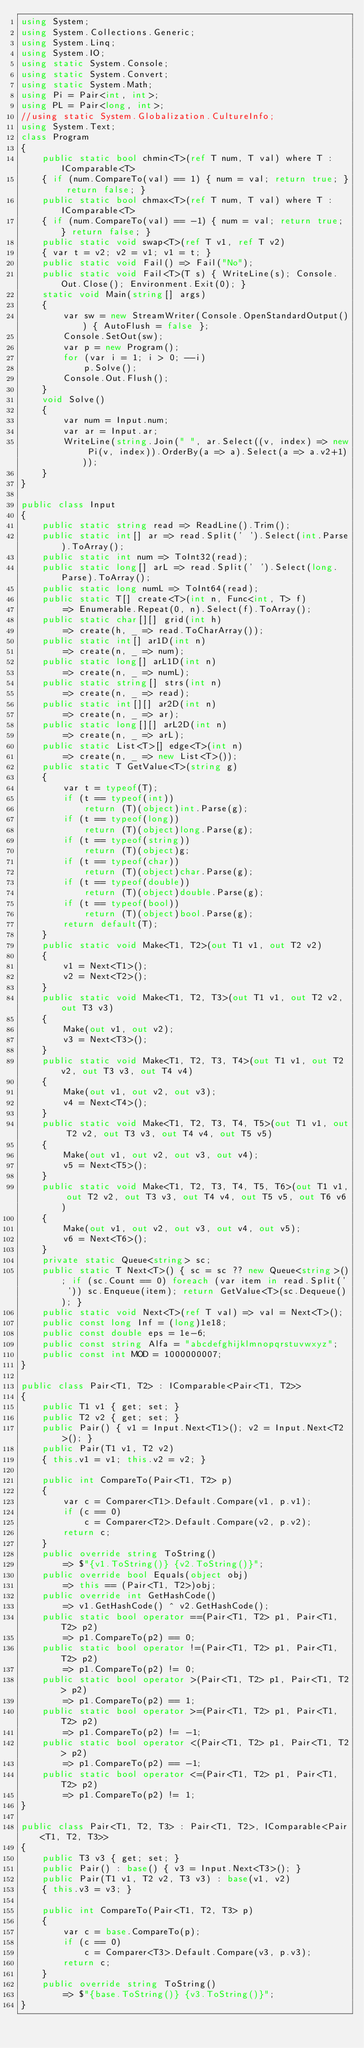<code> <loc_0><loc_0><loc_500><loc_500><_C#_>using System;
using System.Collections.Generic;
using System.Linq;
using System.IO;
using static System.Console;
using static System.Convert;
using static System.Math;
using Pi = Pair<int, int>;
using PL = Pair<long, int>;
//using static System.Globalization.CultureInfo;
using System.Text;
class Program
{
    public static bool chmin<T>(ref T num, T val) where T : IComparable<T>
    { if (num.CompareTo(val) == 1) { num = val; return true; } return false; }
    public static bool chmax<T>(ref T num, T val) where T : IComparable<T>
    { if (num.CompareTo(val) == -1) { num = val; return true; } return false; }
    public static void swap<T>(ref T v1, ref T v2)
    { var t = v2; v2 = v1; v1 = t; }
    public static void Fail() => Fail("No");
    public static void Fail<T>(T s) { WriteLine(s); Console.Out.Close(); Environment.Exit(0); }
    static void Main(string[] args)
    {
        var sw = new StreamWriter(Console.OpenStandardOutput()) { AutoFlush = false };
        Console.SetOut(sw);
        var p = new Program();
        for (var i = 1; i > 0; --i) 
            p.Solve();
        Console.Out.Flush();
    }
    void Solve()
    {
        var num = Input.num;
        var ar = Input.ar;
        WriteLine(string.Join(" ", ar.Select((v, index) => new Pi(v, index)).OrderBy(a => a).Select(a => a.v2+1)));
    }
}

public class Input
{
    public static string read => ReadLine().Trim();
    public static int[] ar => read.Split(' ').Select(int.Parse).ToArray();
    public static int num => ToInt32(read);
    public static long[] arL => read.Split(' ').Select(long.Parse).ToArray();
    public static long numL => ToInt64(read);
    public static T[] create<T>(int n, Func<int, T> f)
        => Enumerable.Repeat(0, n).Select(f).ToArray();
    public static char[][] grid(int h)
        => create(h, _ => read.ToCharArray());
    public static int[] ar1D(int n)
        => create(n, _ => num);
    public static long[] arL1D(int n)
        => create(n, _ => numL);
    public static string[] strs(int n)
        => create(n, _ => read);
    public static int[][] ar2D(int n)
        => create(n, _ => ar);
    public static long[][] arL2D(int n)
        => create(n, _ => arL);
    public static List<T>[] edge<T>(int n)
        => create(n, _ => new List<T>());
    public static T GetValue<T>(string g)
    {
        var t = typeof(T);
        if (t == typeof(int))
            return (T)(object)int.Parse(g);
        if (t == typeof(long))
            return (T)(object)long.Parse(g);
        if (t == typeof(string))
            return (T)(object)g;
        if (t == typeof(char))
            return (T)(object)char.Parse(g);
        if (t == typeof(double))
            return (T)(object)double.Parse(g);
        if (t == typeof(bool))
            return (T)(object)bool.Parse(g);
        return default(T);
    }
    public static void Make<T1, T2>(out T1 v1, out T2 v2)
    {
        v1 = Next<T1>();
        v2 = Next<T2>();
    }
    public static void Make<T1, T2, T3>(out T1 v1, out T2 v2, out T3 v3)
    {
        Make(out v1, out v2);
        v3 = Next<T3>();
    }
    public static void Make<T1, T2, T3, T4>(out T1 v1, out T2 v2, out T3 v3, out T4 v4)
    {
        Make(out v1, out v2, out v3);
        v4 = Next<T4>();
    }
    public static void Make<T1, T2, T3, T4, T5>(out T1 v1, out T2 v2, out T3 v3, out T4 v4, out T5 v5)
    {
        Make(out v1, out v2, out v3, out v4);
        v5 = Next<T5>();
    }
    public static void Make<T1, T2, T3, T4, T5, T6>(out T1 v1, out T2 v2, out T3 v3, out T4 v4, out T5 v5, out T6 v6)
    {
        Make(out v1, out v2, out v3, out v4, out v5);
        v6 = Next<T6>();
    }
    private static Queue<string> sc;
    public static T Next<T>() { sc = sc ?? new Queue<string>(); if (sc.Count == 0) foreach (var item in read.Split(' ')) sc.Enqueue(item); return GetValue<T>(sc.Dequeue()); }
    public static void Next<T>(ref T val) => val = Next<T>();
    public const long Inf = (long)1e18;
    public const double eps = 1e-6;
    public const string Alfa = "abcdefghijklmnopqrstuvwxyz";
    public const int MOD = 1000000007;
}

public class Pair<T1, T2> : IComparable<Pair<T1, T2>>
{
    public T1 v1 { get; set; }
    public T2 v2 { get; set; }
    public Pair() { v1 = Input.Next<T1>(); v2 = Input.Next<T2>(); }
    public Pair(T1 v1, T2 v2)
    { this.v1 = v1; this.v2 = v2; }

    public int CompareTo(Pair<T1, T2> p)
    {
        var c = Comparer<T1>.Default.Compare(v1, p.v1);
        if (c == 0)
            c = Comparer<T2>.Default.Compare(v2, p.v2);
        return c;
    }
    public override string ToString()
        => $"{v1.ToString()} {v2.ToString()}";
    public override bool Equals(object obj)
        => this == (Pair<T1, T2>)obj;
    public override int GetHashCode()
        => v1.GetHashCode() ^ v2.GetHashCode();
    public static bool operator ==(Pair<T1, T2> p1, Pair<T1, T2> p2)
        => p1.CompareTo(p2) == 0;
    public static bool operator !=(Pair<T1, T2> p1, Pair<T1, T2> p2)
        => p1.CompareTo(p2) != 0;
    public static bool operator >(Pair<T1, T2> p1, Pair<T1, T2> p2)
        => p1.CompareTo(p2) == 1;
    public static bool operator >=(Pair<T1, T2> p1, Pair<T1, T2> p2)
        => p1.CompareTo(p2) != -1;
    public static bool operator <(Pair<T1, T2> p1, Pair<T1, T2> p2)
        => p1.CompareTo(p2) == -1;
    public static bool operator <=(Pair<T1, T2> p1, Pair<T1, T2> p2)
        => p1.CompareTo(p2) != 1;
}

public class Pair<T1, T2, T3> : Pair<T1, T2>, IComparable<Pair<T1, T2, T3>>
{
    public T3 v3 { get; set; }
    public Pair() : base() { v3 = Input.Next<T3>(); }
    public Pair(T1 v1, T2 v2, T3 v3) : base(v1, v2)
    { this.v3 = v3; }

    public int CompareTo(Pair<T1, T2, T3> p)
    {
        var c = base.CompareTo(p);
        if (c == 0)
            c = Comparer<T3>.Default.Compare(v3, p.v3);
        return c;
    }
    public override string ToString()
        => $"{base.ToString()} {v3.ToString()}";
}
</code> 